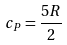<formula> <loc_0><loc_0><loc_500><loc_500>c _ { P } = \frac { 5 R } { 2 }</formula> 